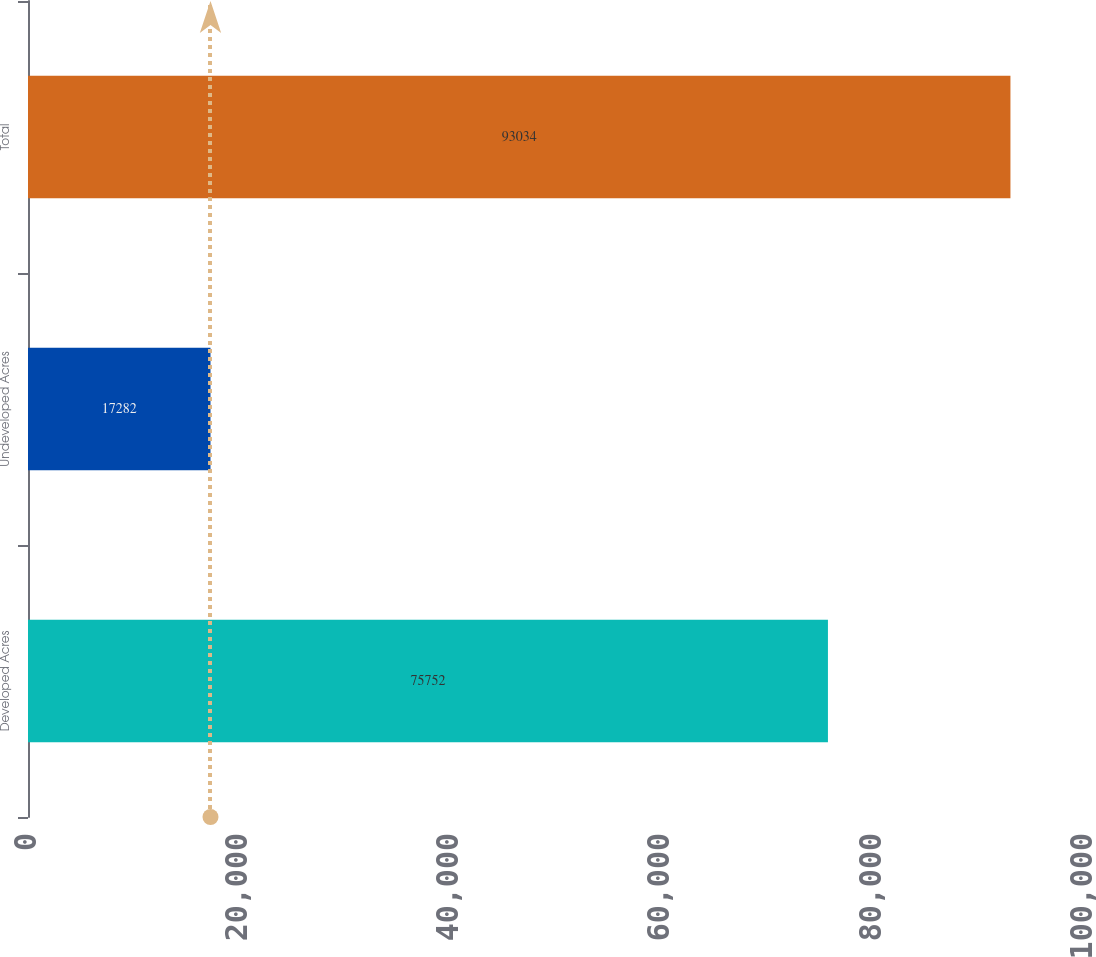Convert chart. <chart><loc_0><loc_0><loc_500><loc_500><bar_chart><fcel>Developed Acres<fcel>Undeveloped Acres<fcel>Total<nl><fcel>75752<fcel>17282<fcel>93034<nl></chart> 